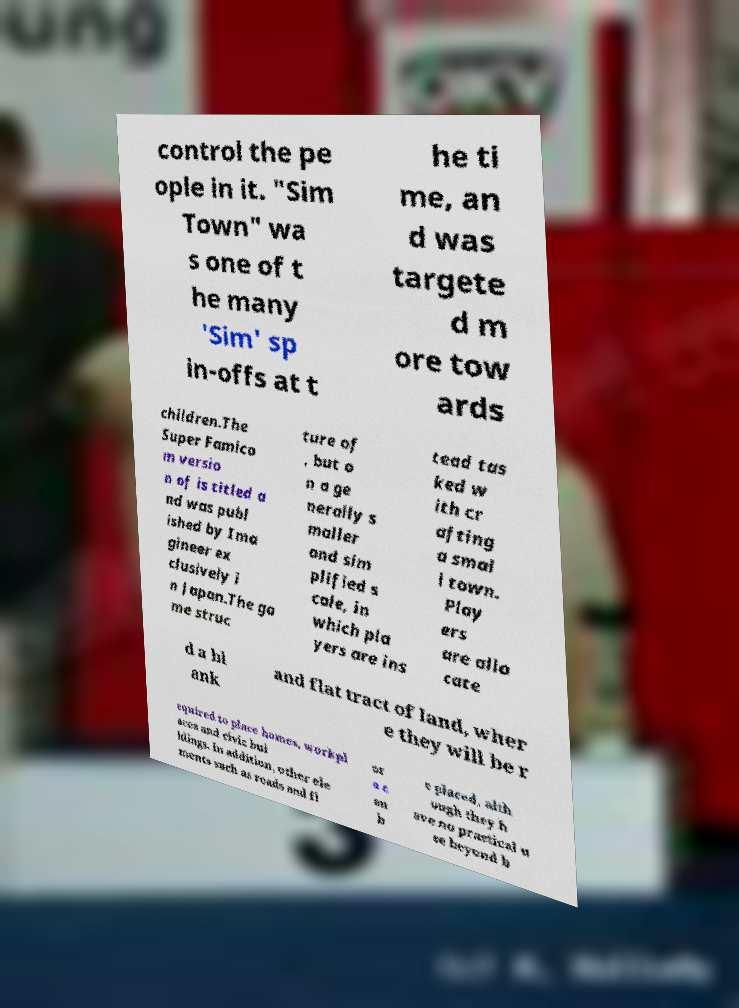There's text embedded in this image that I need extracted. Can you transcribe it verbatim? control the pe ople in it. "Sim Town" wa s one of t he many 'Sim' sp in-offs at t he ti me, an d was targete d m ore tow ards children.The Super Famico m versio n of is titled a nd was publ ished by Ima gineer ex clusively i n Japan.The ga me struc ture of , but o n a ge nerally s maller and sim plified s cale, in which pla yers are ins tead tas ked w ith cr afting a smal l town. Play ers are allo cate d a bl ank and flat tract of land, wher e they will be r equired to place homes, workpl aces and civic bui ldings. In addition, other ele ments such as roads and fl or a c an b e placed, alth ough they h ave no practical u se beyond b 